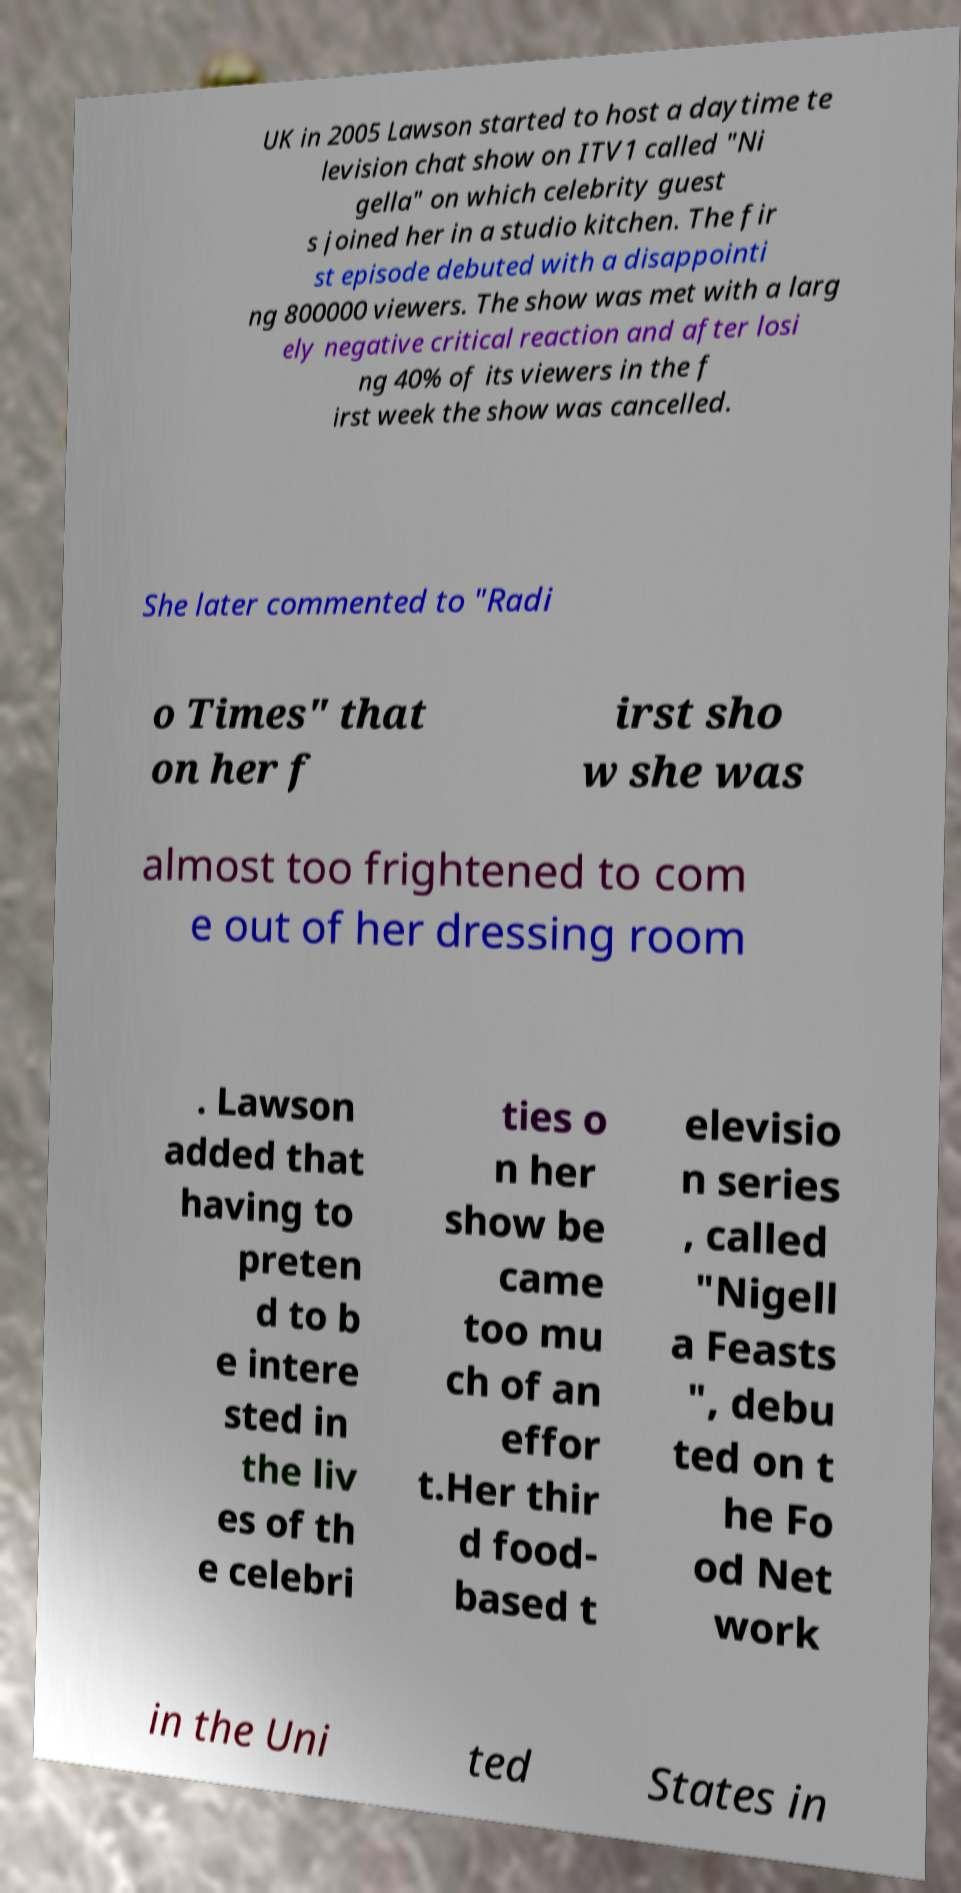What messages or text are displayed in this image? I need them in a readable, typed format. UK in 2005 Lawson started to host a daytime te levision chat show on ITV1 called "Ni gella" on which celebrity guest s joined her in a studio kitchen. The fir st episode debuted with a disappointi ng 800000 viewers. The show was met with a larg ely negative critical reaction and after losi ng 40% of its viewers in the f irst week the show was cancelled. She later commented to "Radi o Times" that on her f irst sho w she was almost too frightened to com e out of her dressing room . Lawson added that having to preten d to b e intere sted in the liv es of th e celebri ties o n her show be came too mu ch of an effor t.Her thir d food- based t elevisio n series , called "Nigell a Feasts ", debu ted on t he Fo od Net work in the Uni ted States in 